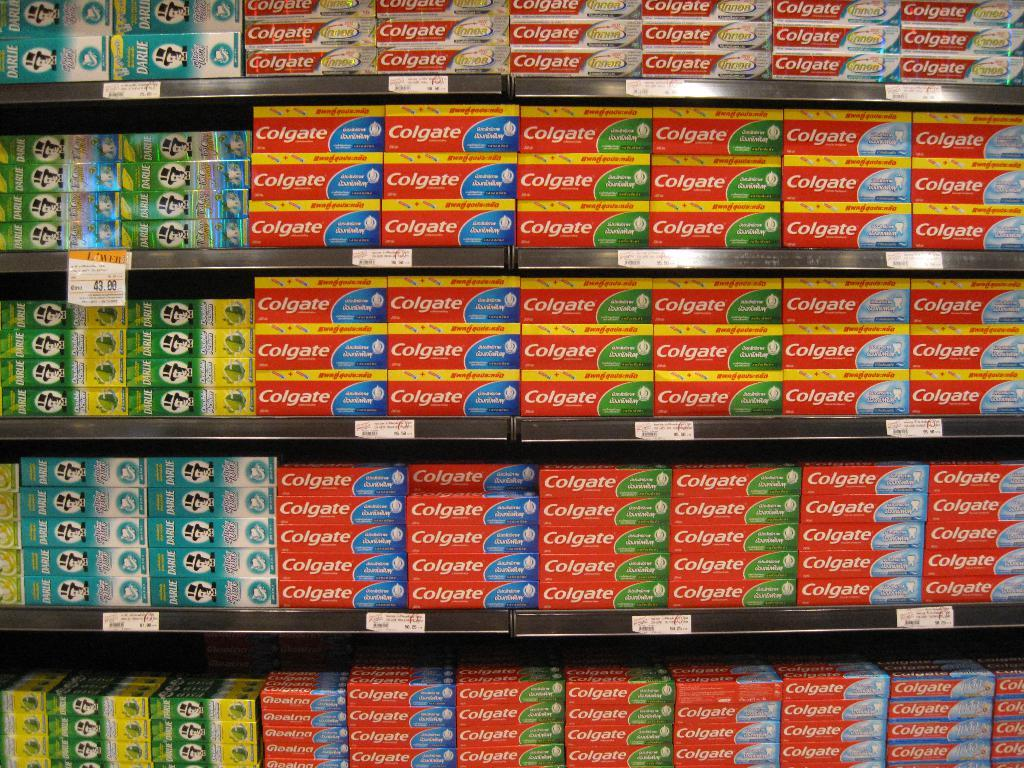<image>
Render a clear and concise summary of the photo. A bunch of shelves with colgate toothpaste on it. 